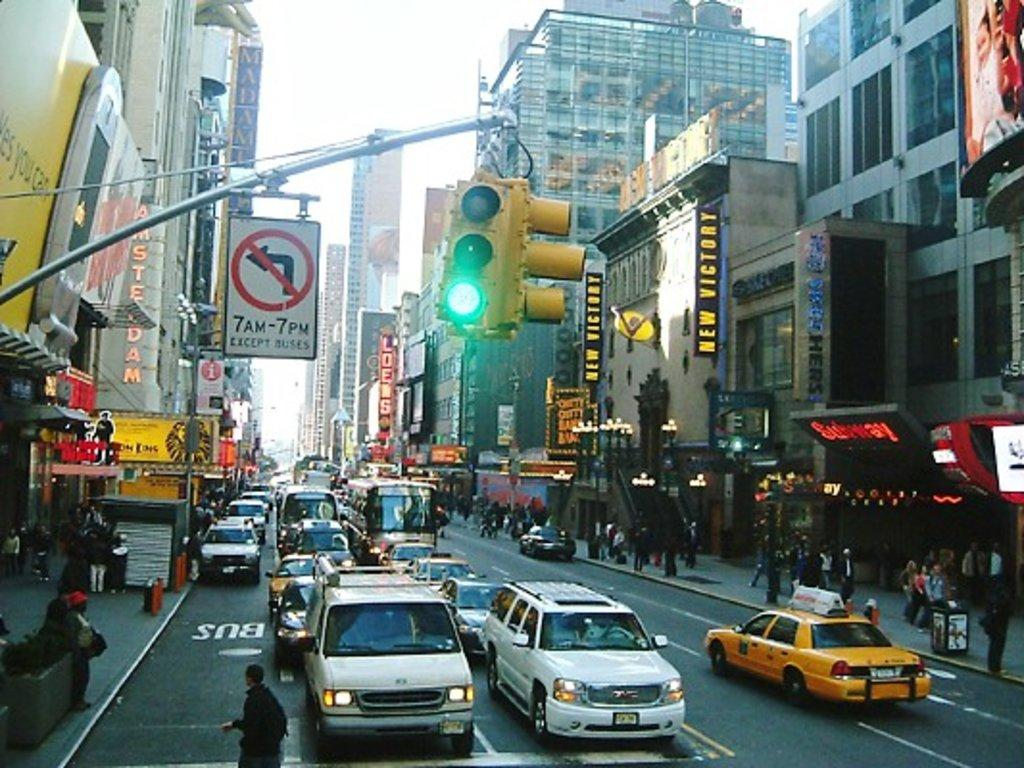<image>
Render a clear and concise summary of the photo. A street with a sign saying you can't turn left from 7 to 7. 